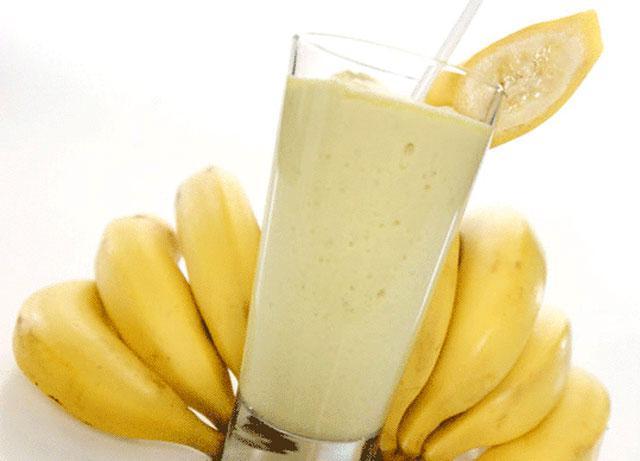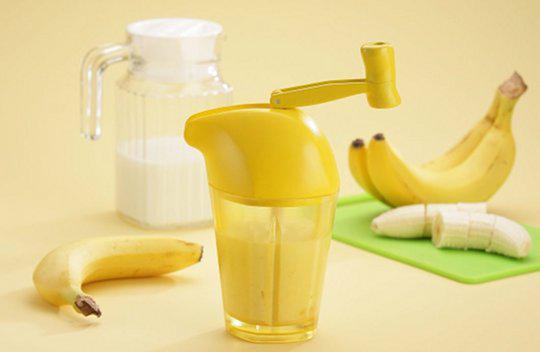The first image is the image on the left, the second image is the image on the right. Given the left and right images, does the statement "The glass in the image to the right, it has a straw in it." hold true? Answer yes or no. No. The first image is the image on the left, the second image is the image on the right. Assess this claim about the two images: "there is a glass of banana smoothie with a straw and at least 4 whole bananas next to it". Correct or not? Answer yes or no. Yes. 